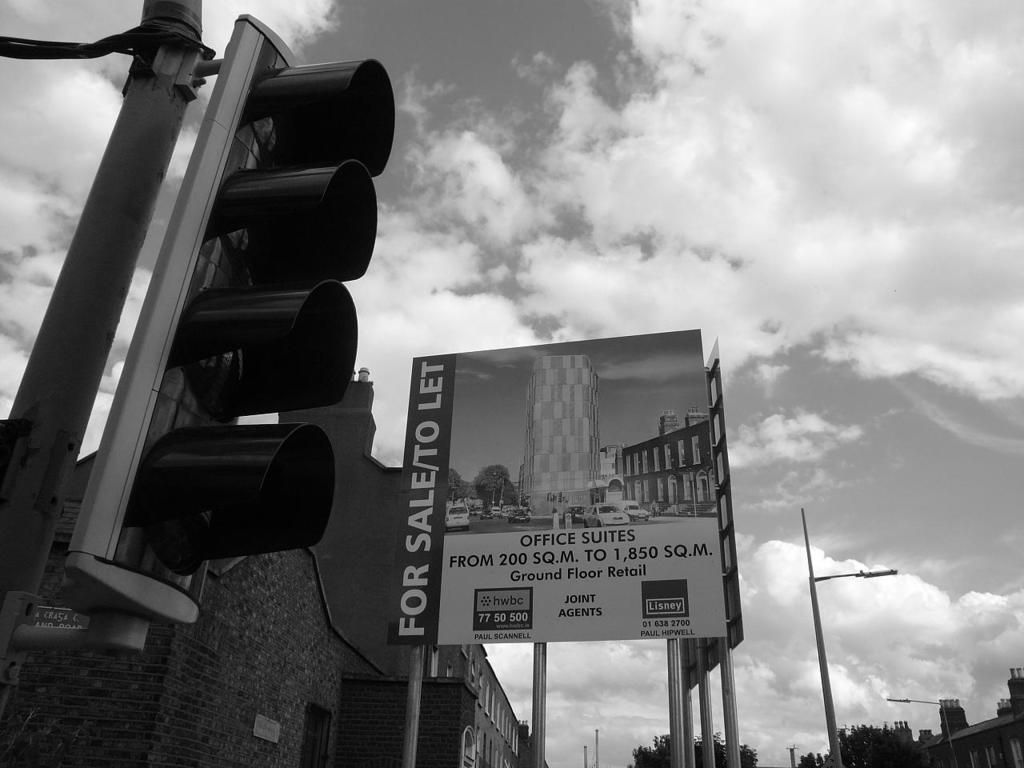What is the main object in the foreground of the image? There is a traffic signal in the image. What can be seen in the background of the image? There is a board attached to a pole, buildings, trees, and the sky visible in the background. What type of structures are present in the image? Light poles are visible in the image. What is the color scheme of the image? The image is in black and white. How many hills can be seen in the image? There are no hills visible in the image. What type of building is the achiever standing in front of in the image? There is no achiever or building present in the image. 